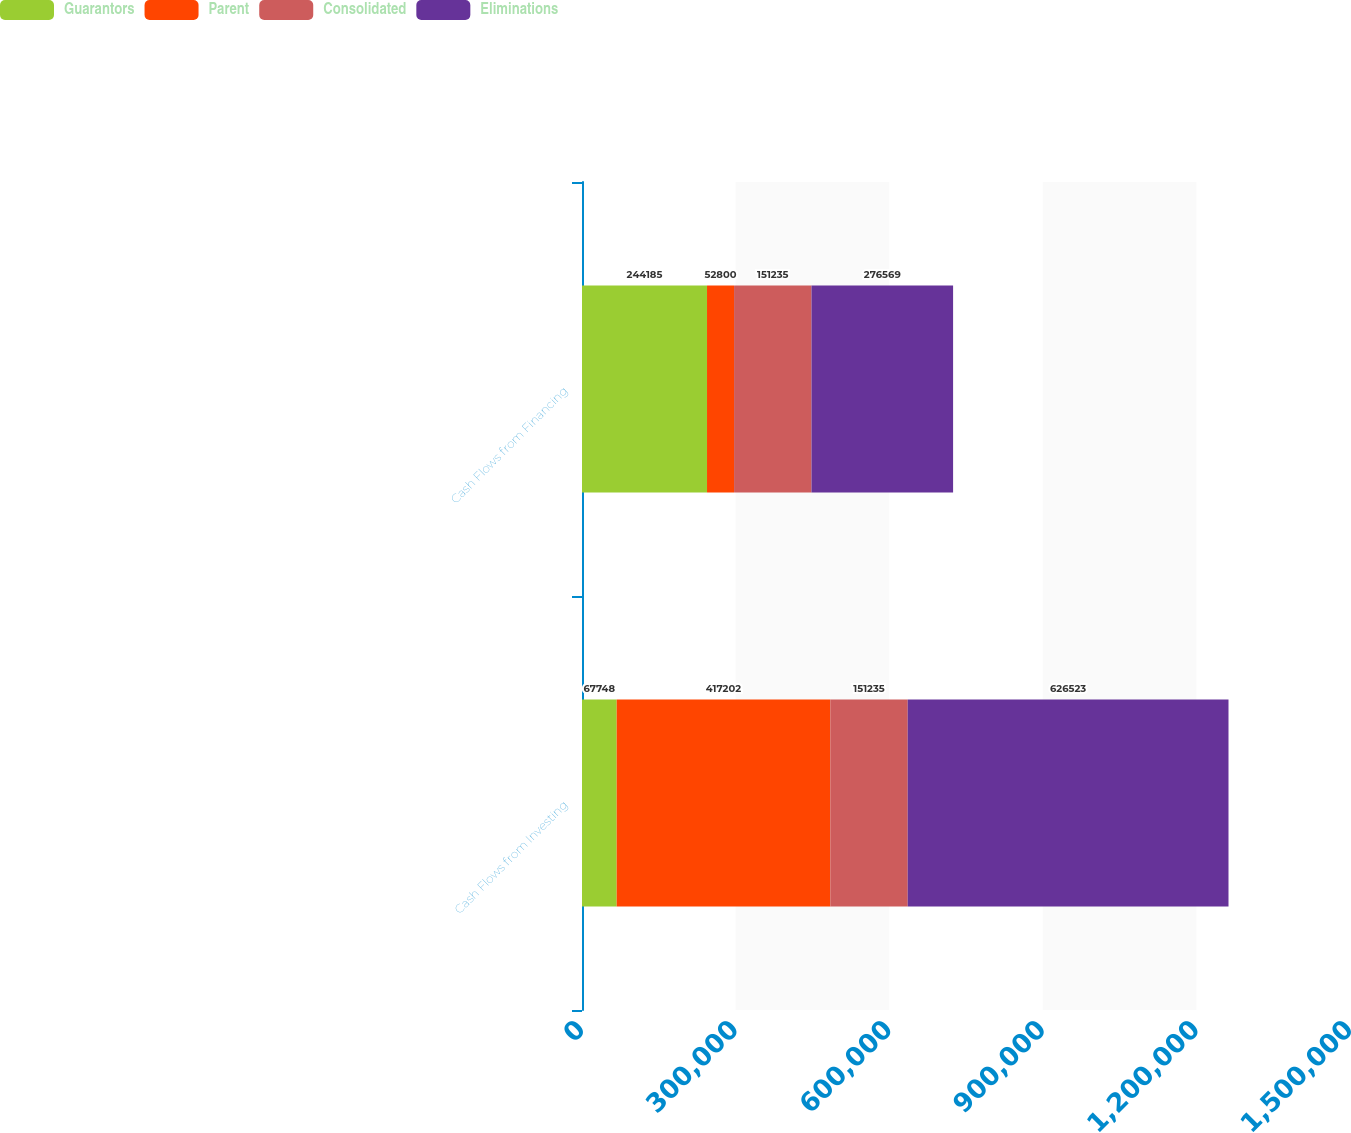Convert chart to OTSL. <chart><loc_0><loc_0><loc_500><loc_500><stacked_bar_chart><ecel><fcel>Cash Flows from Investing<fcel>Cash Flows from Financing<nl><fcel>Guarantors<fcel>67748<fcel>244185<nl><fcel>Parent<fcel>417202<fcel>52800<nl><fcel>Consolidated<fcel>151235<fcel>151235<nl><fcel>Eliminations<fcel>626523<fcel>276569<nl></chart> 